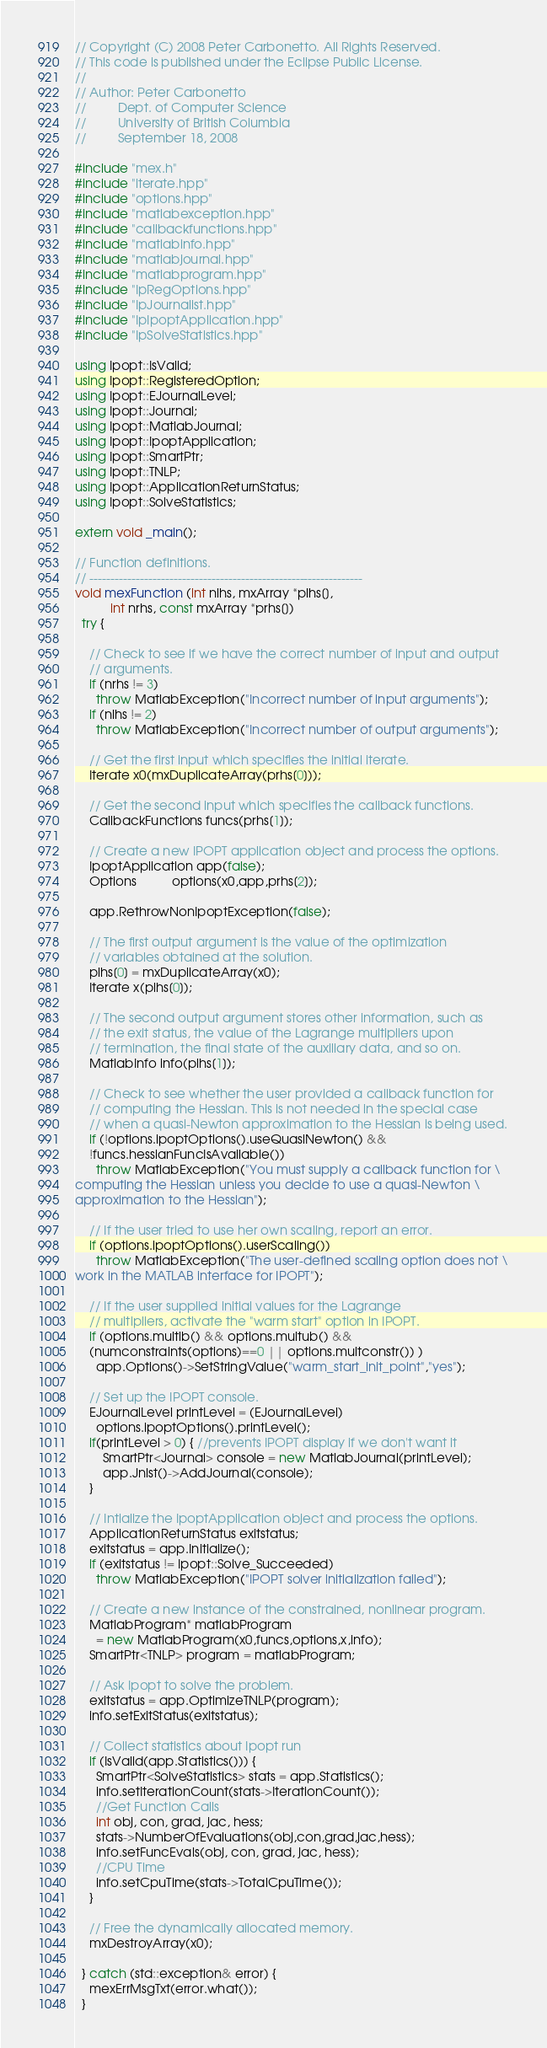Convert code to text. <code><loc_0><loc_0><loc_500><loc_500><_C++_>// Copyright (C) 2008 Peter Carbonetto. All Rights Reserved.
// This code is published under the Eclipse Public License.
//
// Author: Peter Carbonetto
//         Dept. of Computer Science
//         University of British Columbia
//         September 18, 2008

#include "mex.h"
#include "iterate.hpp"
#include "options.hpp"
#include "matlabexception.hpp"
#include "callbackfunctions.hpp"
#include "matlabinfo.hpp"
#include "matlabjournal.hpp"
#include "matlabprogram.hpp"
#include "IpRegOptions.hpp"
#include "IpJournalist.hpp"
#include "IpIpoptApplication.hpp"
#include "IpSolveStatistics.hpp"

using Ipopt::IsValid;
using Ipopt::RegisteredOption;
using Ipopt::EJournalLevel;
using Ipopt::Journal;
using Ipopt::MatlabJournal;
using Ipopt::IpoptApplication;
using Ipopt::SmartPtr;
using Ipopt::TNLP;
using Ipopt::ApplicationReturnStatus;
using Ipopt::SolveStatistics;

extern void _main();

// Function definitions.
// -----------------------------------------------------------------
void mexFunction (int nlhs, mxArray *plhs[], 
		  int nrhs, const mxArray *prhs[]) 
  try {

    // Check to see if we have the correct number of input and output
    // arguments.
    if (nrhs != 3)
      throw MatlabException("Incorrect number of input arguments");
    if (nlhs != 2)
      throw MatlabException("Incorrect number of output arguments");

    // Get the first input which specifies the initial iterate.
    Iterate x0(mxDuplicateArray(prhs[0]));

    // Get the second input which specifies the callback functions.
    CallbackFunctions funcs(prhs[1]);

    // Create a new IPOPT application object and process the options.
    IpoptApplication app(false);
    Options          options(x0,app,prhs[2]);

    app.RethrowNonIpoptException(false);

    // The first output argument is the value of the optimization
    // variables obtained at the solution.
    plhs[0] = mxDuplicateArray(x0);
    Iterate x(plhs[0]);

    // The second output argument stores other information, such as
    // the exit status, the value of the Lagrange multipliers upon
    // termination, the final state of the auxiliary data, and so on.
    MatlabInfo info(plhs[1]);

    // Check to see whether the user provided a callback function for
    // computing the Hessian. This is not needed in the special case
    // when a quasi-Newton approximation to the Hessian is being used.
    if (!options.ipoptOptions().useQuasiNewton() && 
	!funcs.hessianFuncIsAvailable())
      throw MatlabException("You must supply a callback function for \
computing the Hessian unless you decide to use a quasi-Newton \
approximation to the Hessian");

    // If the user tried to use her own scaling, report an error.
    if (options.ipoptOptions().userScaling())
      throw MatlabException("The user-defined scaling option does not \
work in the MATLAB interface for IPOPT");

    // If the user supplied initial values for the Lagrange
    // multipliers, activate the "warm start" option in IPOPT.
    if (options.multlb() && options.multub() &&
	(numconstraints(options)==0 || options.multconstr()) )
      app.Options()->SetStringValue("warm_start_init_point","yes");

    // Set up the IPOPT console.
    EJournalLevel printLevel = (EJournalLevel) 
      options.ipoptOptions().printLevel();
    if(printLevel > 0) { //prevents IPOPT display if we don't want it
        SmartPtr<Journal> console = new MatlabJournal(printLevel);
        app.Jnlst()->AddJournal(console);
    }

    // Intialize the IpoptApplication object and process the options.
    ApplicationReturnStatus exitstatus;
    exitstatus = app.Initialize();
    if (exitstatus != Ipopt::Solve_Succeeded)
      throw MatlabException("IPOPT solver initialization failed");

    // Create a new instance of the constrained, nonlinear program.
    MatlabProgram* matlabProgram 
      = new MatlabProgram(x0,funcs,options,x,info);
    SmartPtr<TNLP> program = matlabProgram;

    // Ask Ipopt to solve the problem.
    exitstatus = app.OptimizeTNLP(program);
    info.setExitStatus(exitstatus);

    // Collect statistics about Ipopt run
    if (IsValid(app.Statistics())) {
      SmartPtr<SolveStatistics> stats = app.Statistics();
      info.setIterationCount(stats->IterationCount());
      //Get Function Calls
      int obj, con, grad, jac, hess;
      stats->NumberOfEvaluations(obj,con,grad,jac,hess);
      info.setFuncEvals(obj, con, grad, jac, hess);      
      //CPU Time
      info.setCpuTime(stats->TotalCpuTime());
    }

    // Free the dynamically allocated memory.
    mxDestroyArray(x0);

  } catch (std::exception& error) {
    mexErrMsgTxt(error.what());
  }
</code> 